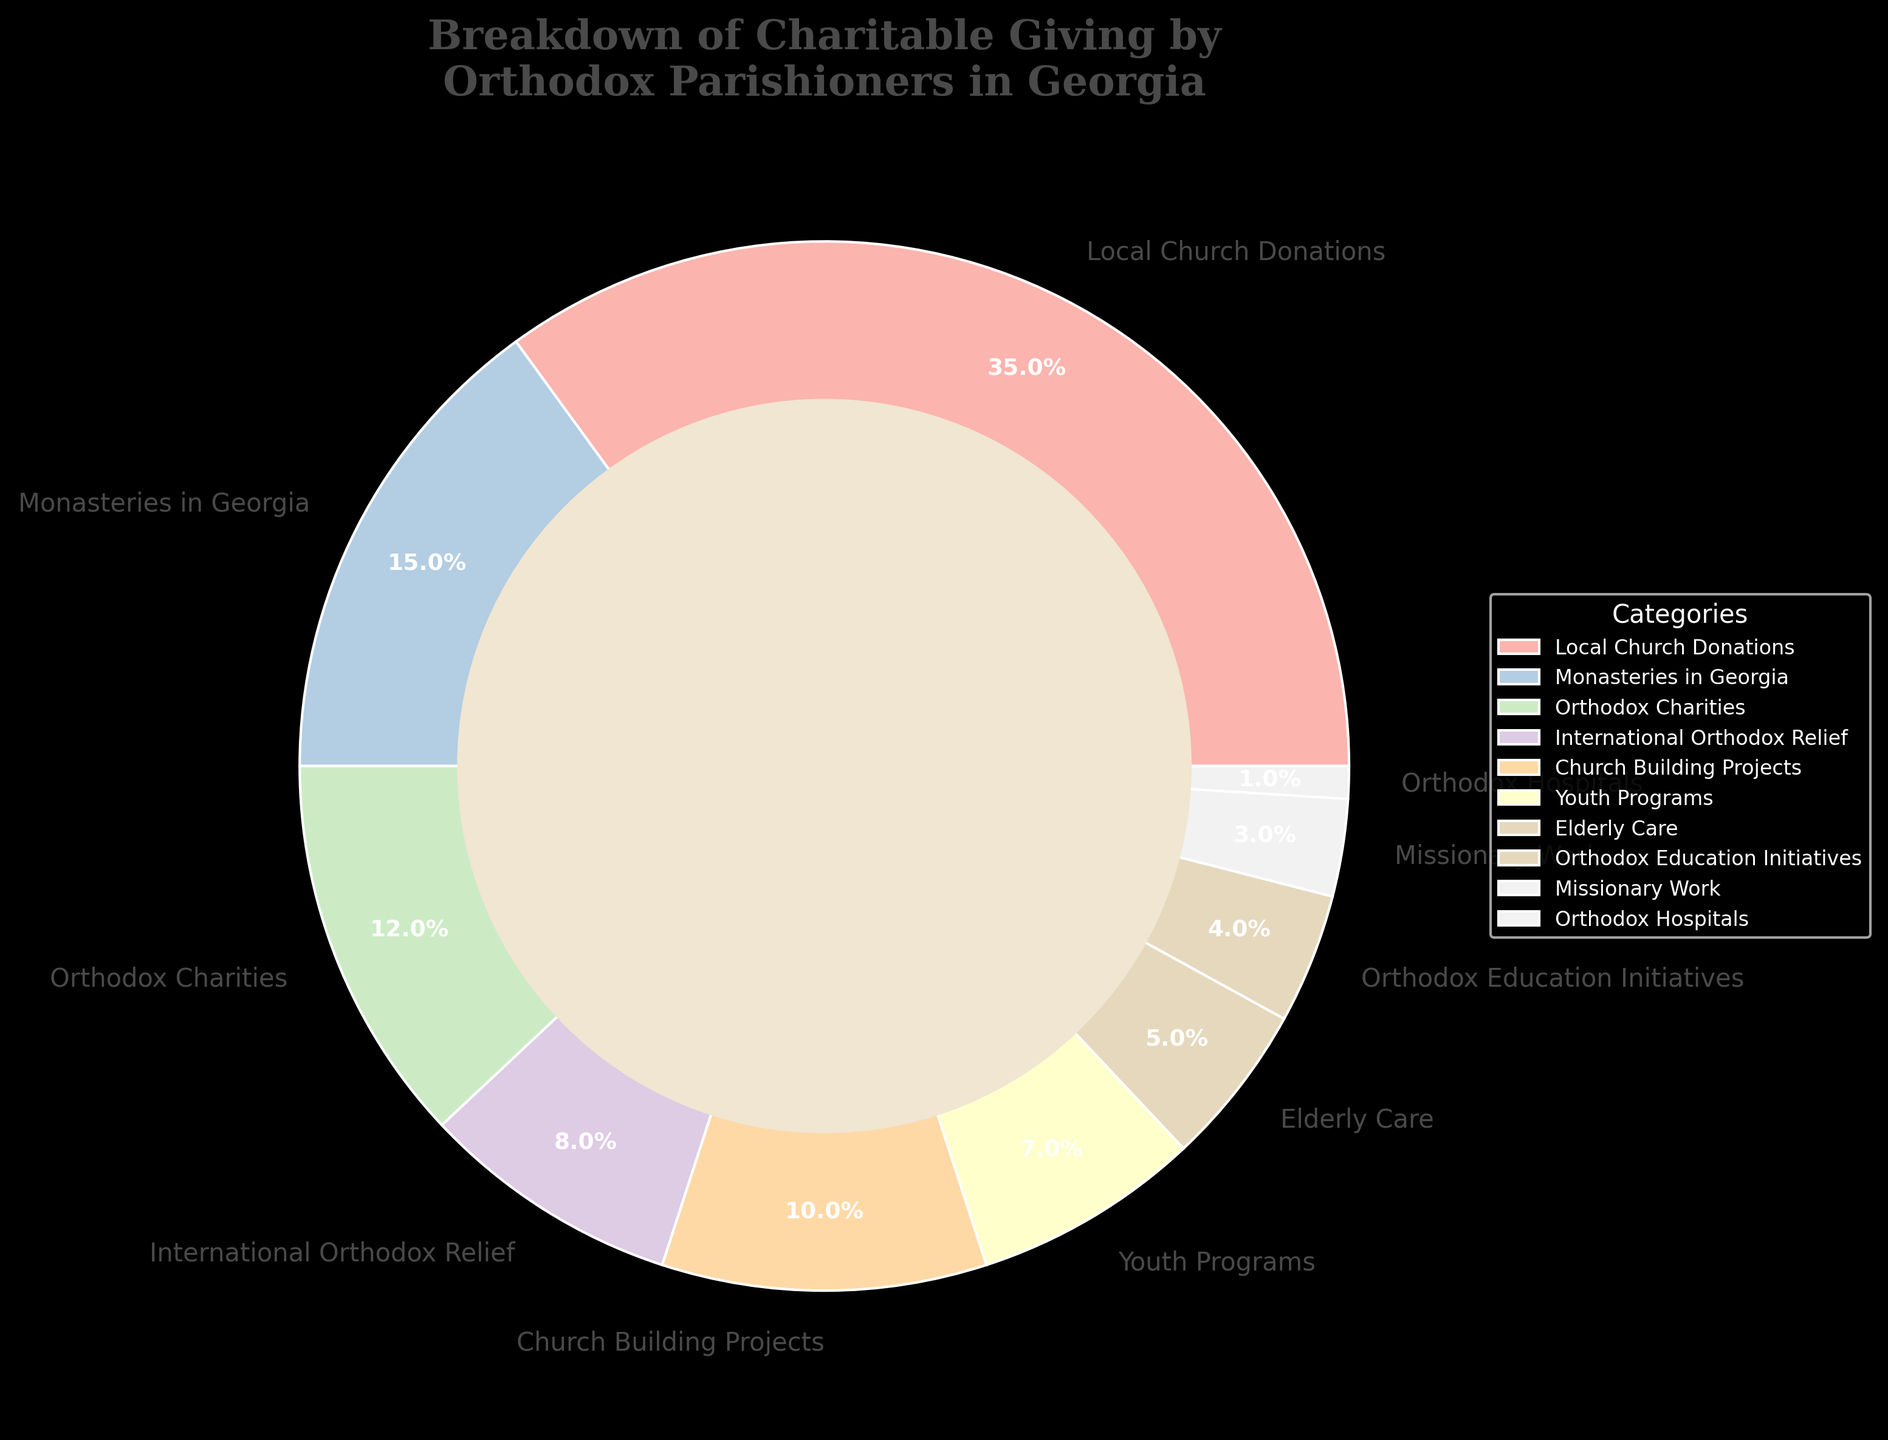Which category has the highest percentage of charitable giving? The category with the highest percentage can be identified by locating the largest segment of the pie chart. The largest segment is labeled "Local Church Donations."
Answer: Local Church Donations Which categories have percentages higher than 10%? To answer this, look at the labels and identify the segments that show percentages above 10%. The segments labeled "Local Church Donations," "Monasteries in Georgia," and "Orthodox Charities" all have percentages more than 10%.
Answer: Local Church Donations, Monasteries in Georgia, Orthodox Charities What is the combined percentage for "Youth Programs" and "Elderly Care"? Find the percentages for both "Youth Programs" and "Elderly Care" by looking at their respective segments. Add these percentages together: 7% (Youth Programs) + 5% (Elderly Care) = 12%.
Answer: 12% Which category is represented by the smallest segment in the pie chart? Identify the smallest slice in the pie chart. The smallest slice is labeled "Orthodox Hospitals."
Answer: Orthodox Hospitals How much greater is the percentage of "Local Church Donations" compared to "International Orthodox Relief"? Find the percentages for both categories and subtract the smaller percentage from the larger one: 35% (Local Church Donations) - 8% (International Orthodox Relief) = 27%.
Answer: 27% What percentage of charitable giving is directed towards categories that involve care for specific age groups (Youth Programs and Elderly Care)? Locate the segments for "Youth Programs" and "Elderly Care" and add their percentages together. This is a matter of adding 7% (Youth Programs) and 5% (Elderly Care), resulting in 12%.
Answer: 12% Is the percentage of "Church Building Projects" more or less than twice the percentage for "Orthodox Education Initiatives"? Check the percentages for both categories. Compare twice the percentage of "Orthodox Education Initiatives" (2 * 4% = 8%) to that of "Church Building Projects" (10%). Since 10% > 8%, the percentage for "Church Building Projects" is more than twice that of "Orthodox Education Initiatives."
Answer: More What is the combined percentage for categories related to healthcare and relief (Orthodox Hospitals and International Orthodox Relief)? Sum the percentages of "Orthodox Hospitals" and "International Orthodox Relief." Add 1% (Orthodox Hospitals) and 8% (International Orthodox Relief) for a total of 9%.
Answer: 9% How does the percentage for "Monasteries in Georgia" compare to that of "Church Building Projects"? Compare the segments labeled "Monasteries in Georgia" (15%) and "Church Building Projects" (10%). The percentage for "Monasteries in Georgia" is greater.
Answer: Greater What is the difference in percentage between "Orthodox Charities" and "Missionary Work"? Subtract the percentage for "Missionary Work" (3%) from the percentage for "Orthodox Charities" (12%). The result is 12% - 3% = 9%.
Answer: 9% 